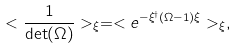Convert formula to latex. <formula><loc_0><loc_0><loc_500><loc_500>< \frac { 1 } { \det ( \Omega ) } > _ { \xi } = < e ^ { - \xi ^ { \dagger } ( \Omega - 1 ) \xi } > _ { \xi } ,</formula> 